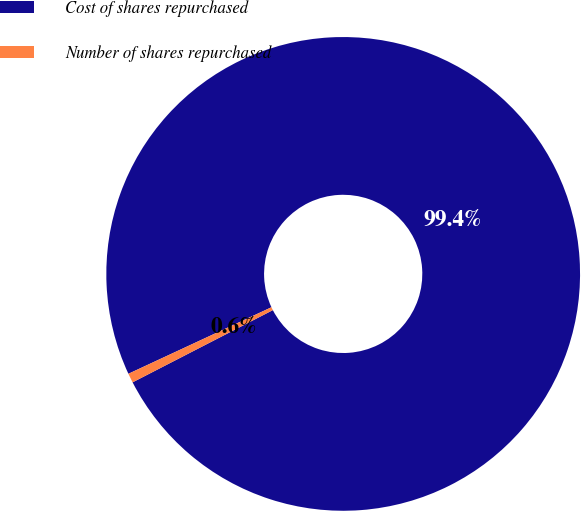Convert chart to OTSL. <chart><loc_0><loc_0><loc_500><loc_500><pie_chart><fcel>Cost of shares repurchased<fcel>Number of shares repurchased<nl><fcel>99.36%<fcel>0.64%<nl></chart> 